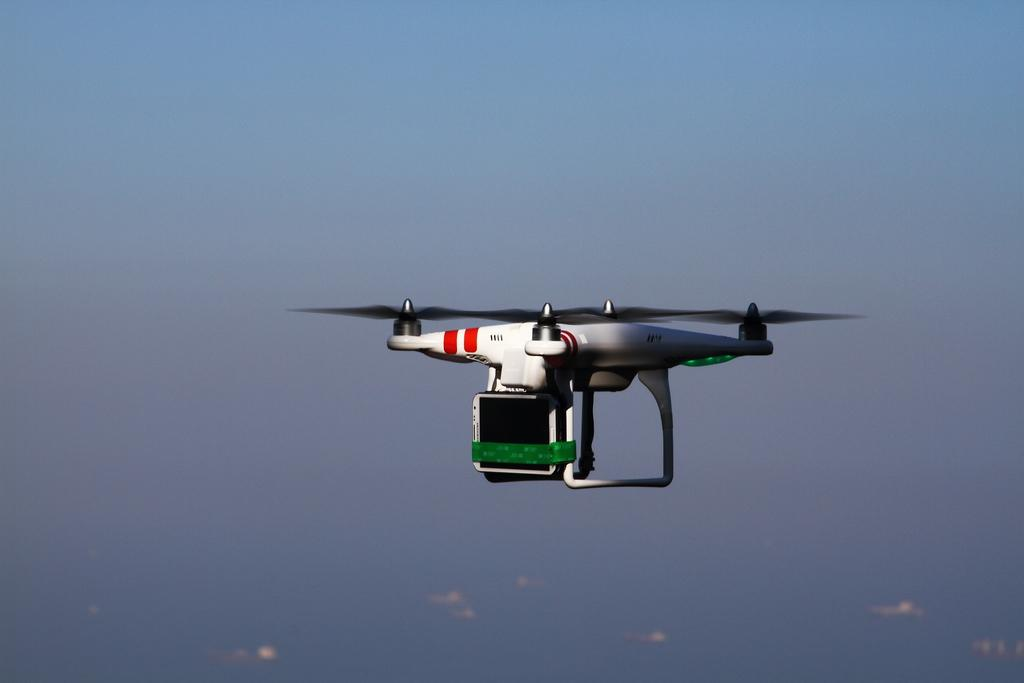What is the main subject of the image? The main subject of the image is a remote controlled drone. What is the drone doing in the image? The drone is flying in the sky. What can be seen in the background of the image? The sky is visible in the background of the image. What is the color of the sky in the image? The color of the sky in the image is blue. What type of knowledge can be gained from the drone's journey in the image? There is no journey or knowledge acquisition mentioned in the image; it simply shows a drone flying in the sky. 